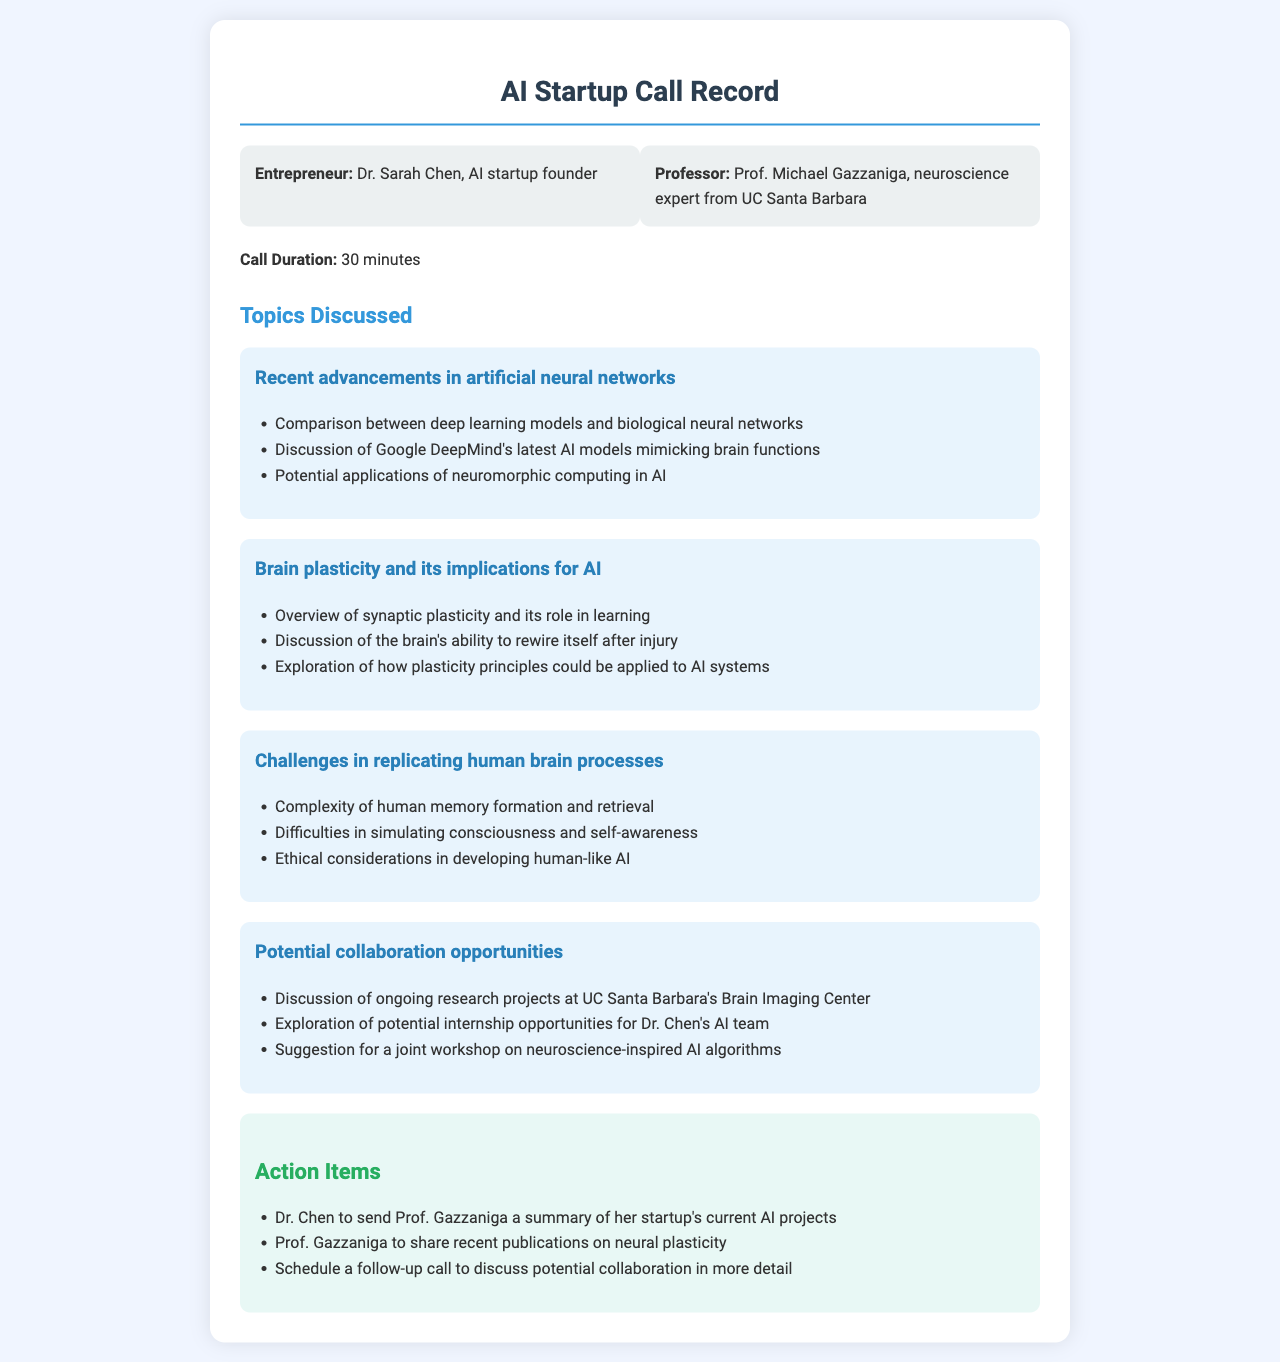What is the name of the entrepreneur? The document provides the name of the entrepreneur as Dr. Sarah Chen.
Answer: Dr. Sarah Chen Who is the professor discussed in the call? The professor's name mentioned in the document is Prof. Michael Gazzaniga.
Answer: Prof. Michael Gazzaniga How long was the call? The call duration is explicitly stated in the document as 30 minutes.
Answer: 30 minutes What university is Prof. Gazzaniga affiliated with? The document states that Prof. Gazzaniga is from UC Santa Barbara.
Answer: UC Santa Barbara What was one topic discussed related to brain plasticity? The document mentions synaptic plasticity and its role in learning as a discussion topic.
Answer: Synaptic plasticity and its role in learning What is one challenge in replicating human brain processes? The document lists the complexity of human memory formation and retrieval as a challenge.
Answer: Complexity of human memory formation and retrieval What collaboration opportunity was discussed? The suggestion for a joint workshop on neuroscience-inspired AI algorithms is mentioned as a collaboration opportunity.
Answer: Joint workshop on neuroscience-inspired AI algorithms What action item involves a follow-up? The document states that a follow-up call needs to be scheduled to discuss potential collaboration in more detail.
Answer: Schedule a follow-up call What type of recent publications will Prof. Gazzaniga share? The action item mentions that Prof. Gazzaniga will share recent publications on neural plasticity.
Answer: Recent publications on neural plasticity 